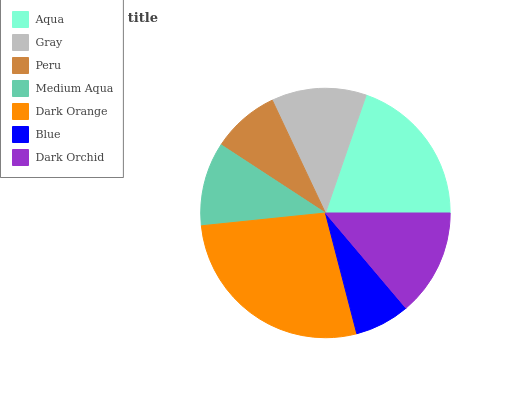Is Blue the minimum?
Answer yes or no. Yes. Is Dark Orange the maximum?
Answer yes or no. Yes. Is Gray the minimum?
Answer yes or no. No. Is Gray the maximum?
Answer yes or no. No. Is Aqua greater than Gray?
Answer yes or no. Yes. Is Gray less than Aqua?
Answer yes or no. Yes. Is Gray greater than Aqua?
Answer yes or no. No. Is Aqua less than Gray?
Answer yes or no. No. Is Gray the high median?
Answer yes or no. Yes. Is Gray the low median?
Answer yes or no. Yes. Is Blue the high median?
Answer yes or no. No. Is Dark Orchid the low median?
Answer yes or no. No. 